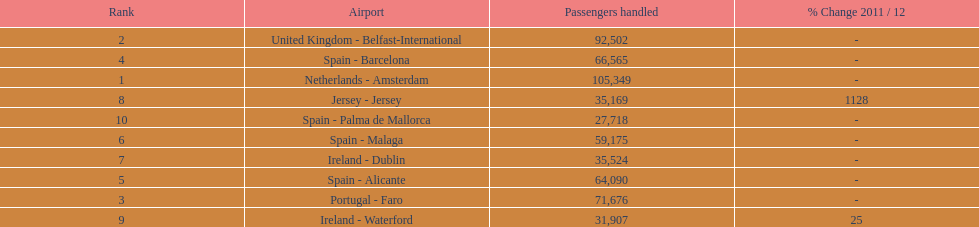How many passengers are going to or coming from spain? 217,548. 